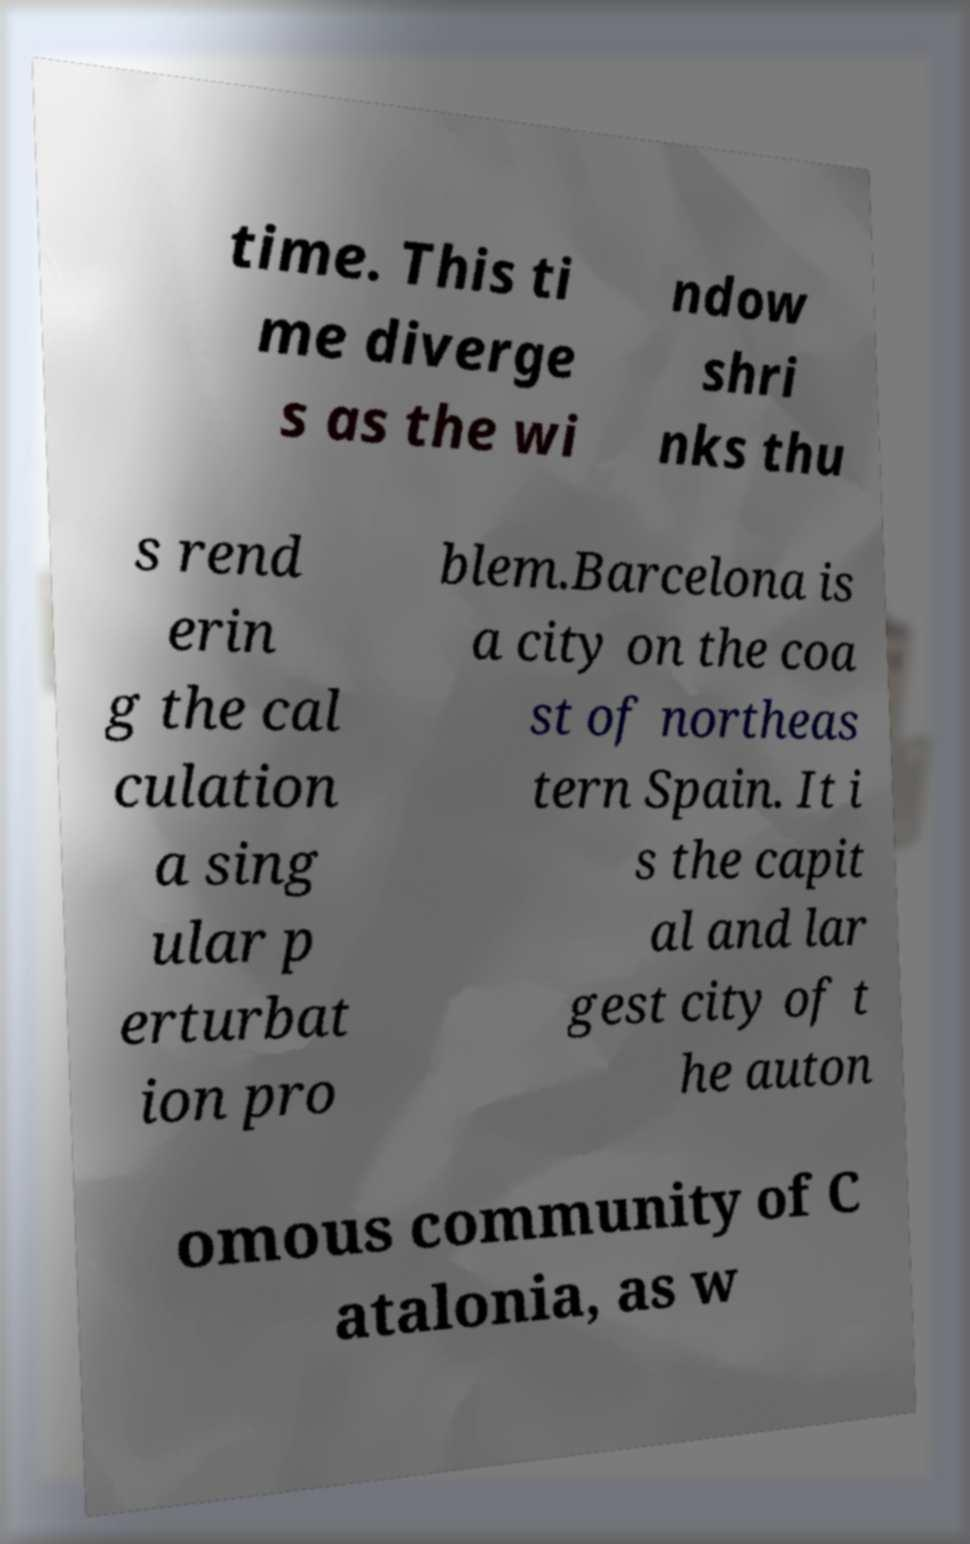For documentation purposes, I need the text within this image transcribed. Could you provide that? time. This ti me diverge s as the wi ndow shri nks thu s rend erin g the cal culation a sing ular p erturbat ion pro blem.Barcelona is a city on the coa st of northeas tern Spain. It i s the capit al and lar gest city of t he auton omous community of C atalonia, as w 